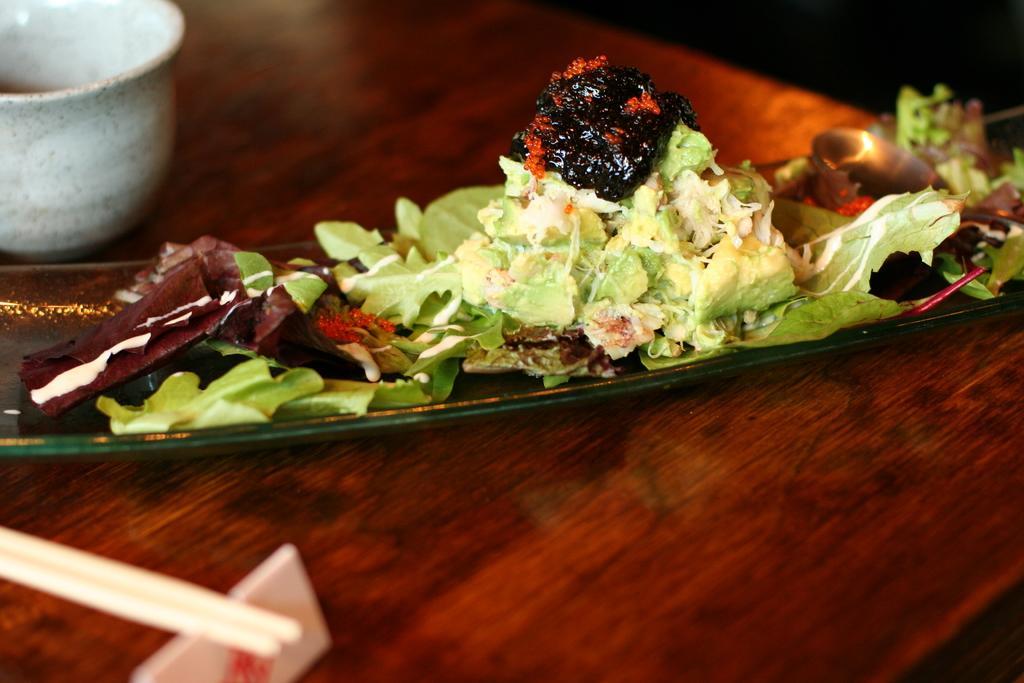In one or two sentences, can you explain what this image depicts? In this picture we can see food on an object and the object is on the wooden surface. On the wooden surface, there are chopsticks and a cup. 